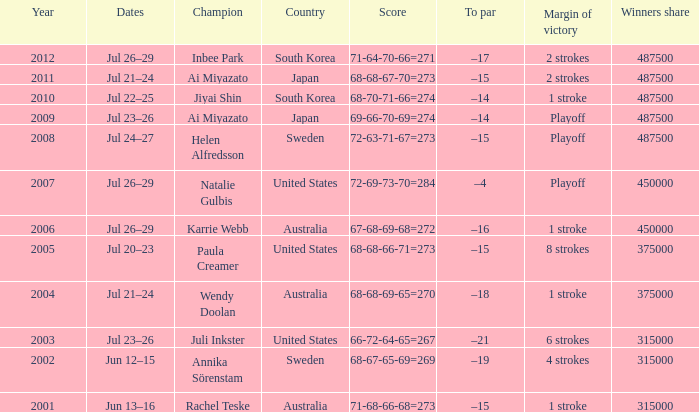How many dollars is the purse when the margin of victory is 8 strokes? 1.0. 